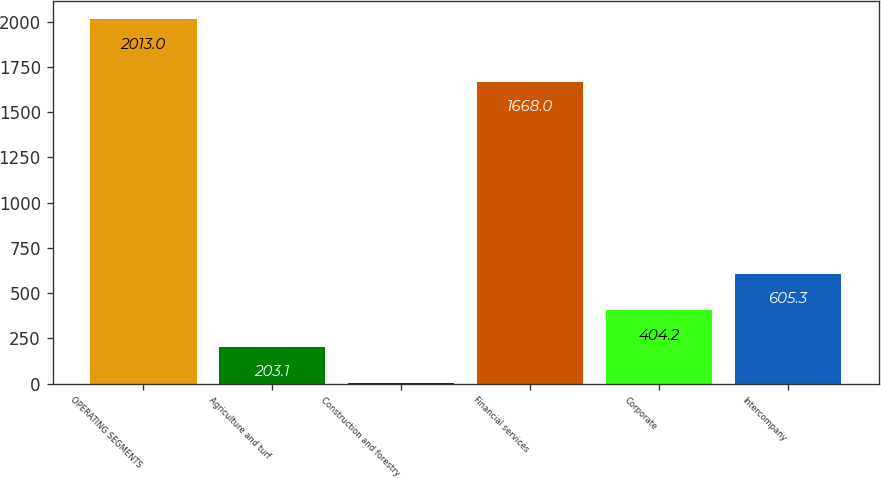Convert chart to OTSL. <chart><loc_0><loc_0><loc_500><loc_500><bar_chart><fcel>OPERATING SEGMENTS<fcel>Agriculture and turf<fcel>Construction and forestry<fcel>Financial services<fcel>Corporate<fcel>Intercompany<nl><fcel>2013<fcel>203.1<fcel>2<fcel>1668<fcel>404.2<fcel>605.3<nl></chart> 